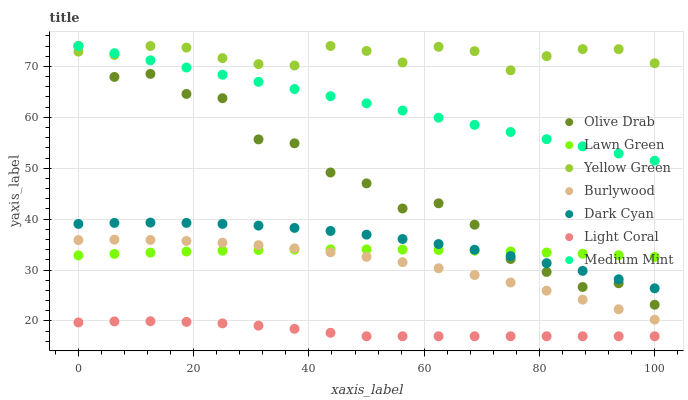Does Light Coral have the minimum area under the curve?
Answer yes or no. Yes. Does Yellow Green have the maximum area under the curve?
Answer yes or no. Yes. Does Lawn Green have the minimum area under the curve?
Answer yes or no. No. Does Lawn Green have the maximum area under the curve?
Answer yes or no. No. Is Medium Mint the smoothest?
Answer yes or no. Yes. Is Olive Drab the roughest?
Answer yes or no. Yes. Is Lawn Green the smoothest?
Answer yes or no. No. Is Lawn Green the roughest?
Answer yes or no. No. Does Light Coral have the lowest value?
Answer yes or no. Yes. Does Lawn Green have the lowest value?
Answer yes or no. No. Does Olive Drab have the highest value?
Answer yes or no. Yes. Does Lawn Green have the highest value?
Answer yes or no. No. Is Lawn Green less than Yellow Green?
Answer yes or no. Yes. Is Olive Drab greater than Burlywood?
Answer yes or no. Yes. Does Dark Cyan intersect Olive Drab?
Answer yes or no. Yes. Is Dark Cyan less than Olive Drab?
Answer yes or no. No. Is Dark Cyan greater than Olive Drab?
Answer yes or no. No. Does Lawn Green intersect Yellow Green?
Answer yes or no. No. 